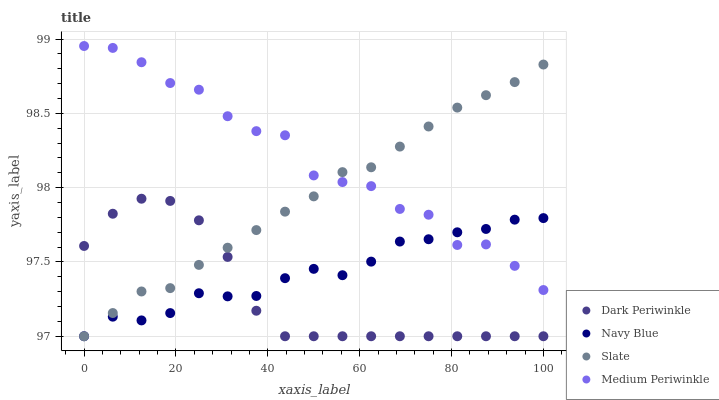Does Dark Periwinkle have the minimum area under the curve?
Answer yes or no. Yes. Does Medium Periwinkle have the maximum area under the curve?
Answer yes or no. Yes. Does Slate have the minimum area under the curve?
Answer yes or no. No. Does Slate have the maximum area under the curve?
Answer yes or no. No. Is Slate the smoothest?
Answer yes or no. Yes. Is Medium Periwinkle the roughest?
Answer yes or no. Yes. Is Medium Periwinkle the smoothest?
Answer yes or no. No. Is Slate the roughest?
Answer yes or no. No. Does Navy Blue have the lowest value?
Answer yes or no. Yes. Does Medium Periwinkle have the lowest value?
Answer yes or no. No. Does Medium Periwinkle have the highest value?
Answer yes or no. Yes. Does Slate have the highest value?
Answer yes or no. No. Is Dark Periwinkle less than Medium Periwinkle?
Answer yes or no. Yes. Is Medium Periwinkle greater than Dark Periwinkle?
Answer yes or no. Yes. Does Navy Blue intersect Slate?
Answer yes or no. Yes. Is Navy Blue less than Slate?
Answer yes or no. No. Is Navy Blue greater than Slate?
Answer yes or no. No. Does Dark Periwinkle intersect Medium Periwinkle?
Answer yes or no. No. 